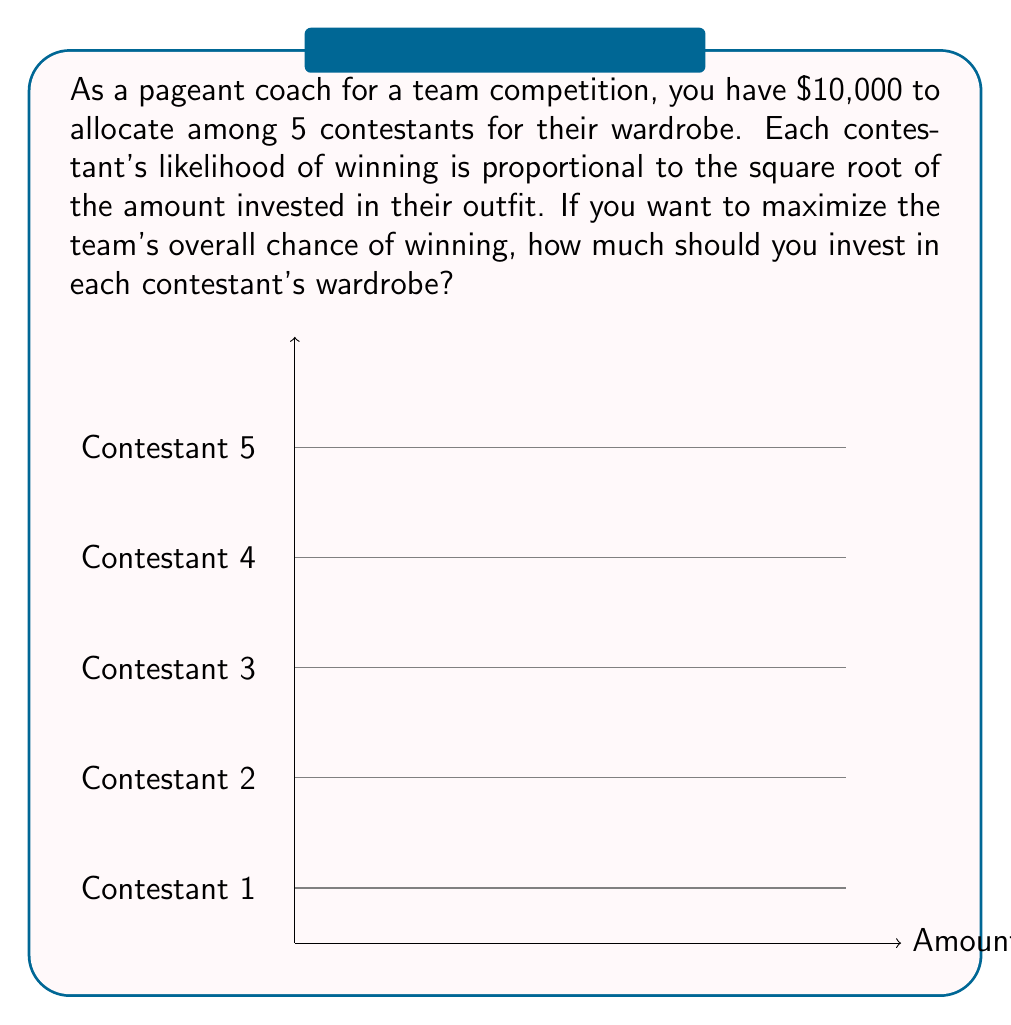Show me your answer to this math problem. Let's approach this step-by-step:

1) Let $x_i$ be the amount invested in contestant i's wardrobe.

2) The total budget constraint is:
   $$x_1 + x_2 + x_3 + x_4 + x_5 = 10000$$

3) The likelihood of winning for each contestant is proportional to $\sqrt{x_i}$.

4) To maximize the team's overall chance of winning, we need to maximize the sum of these likelihoods:
   $$\text{maximize } f(x_1,x_2,x_3,x_4,x_5) = \sqrt{x_1} + \sqrt{x_2} + \sqrt{x_3} + \sqrt{x_4} + \sqrt{x_5}$$

5) This is a constrained optimization problem. We can solve it using the method of Lagrange multipliers.

6) The Lagrangian function is:
   $$L = \sqrt{x_1} + \sqrt{x_2} + \sqrt{x_3} + \sqrt{x_4} + \sqrt{x_5} - \lambda(x_1 + x_2 + x_3 + x_4 + x_5 - 10000)$$

7) Taking partial derivatives and setting them to zero:
   $$\frac{\partial L}{\partial x_i} = \frac{1}{2\sqrt{x_i}} - \lambda = 0 \text{ for } i = 1,2,3,4,5$$

8) This implies that $x_1 = x_2 = x_3 = x_4 = x_5$.

9) Given the budget constraint, we can conclude:
   $$x_1 = x_2 = x_3 = x_4 = x_5 = \frac{10000}{5} = 2000$$

Therefore, to maximize the team's chance of winning, you should invest $2000 in each contestant's wardrobe.
Answer: $2000 per contestant 